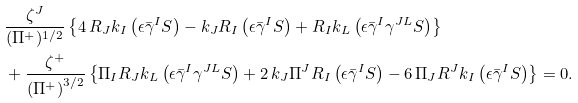<formula> <loc_0><loc_0><loc_500><loc_500>& \frac { \zeta ^ { J } } { ( \Pi ^ { + } ) ^ { 1 / 2 } } \left \{ 4 \, R _ { J } k _ { I } \left ( \epsilon \bar { \gamma } ^ { I } S \right ) - k _ { J } R _ { I } \left ( \epsilon \bar { \gamma } ^ { I } S \right ) + R _ { I } k _ { L } \left ( \epsilon \bar { \gamma } ^ { I } \gamma ^ { J L } S \right ) \right \} \\ & + \frac { \zeta ^ { + } } { \left ( \Pi ^ { + } \right ) ^ { 3 / 2 } } \left \{ \Pi _ { I } R _ { J } k _ { L } \left ( \epsilon \bar { \gamma } ^ { I } \gamma ^ { J L } S \right ) + 2 \, k _ { J } \Pi ^ { J } R _ { I } \left ( \epsilon \bar { \gamma } ^ { I } S \right ) - 6 \, \Pi _ { J } R ^ { J } k _ { I } \left ( \epsilon \bar { \gamma } ^ { I } S \right ) \right \} = 0 .</formula> 